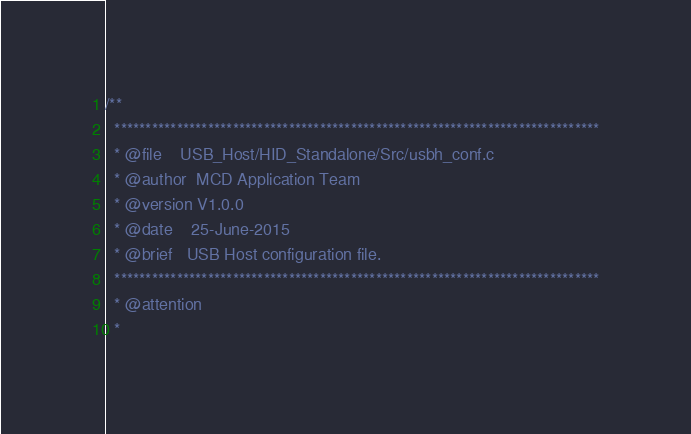<code> <loc_0><loc_0><loc_500><loc_500><_C_>/**
  ******************************************************************************
  * @file    USB_Host/HID_Standalone/Src/usbh_conf.c
  * @author  MCD Application Team
  * @version V1.0.0
  * @date    25-June-2015
  * @brief   USB Host configuration file.
  ******************************************************************************
  * @attention
  *</code> 